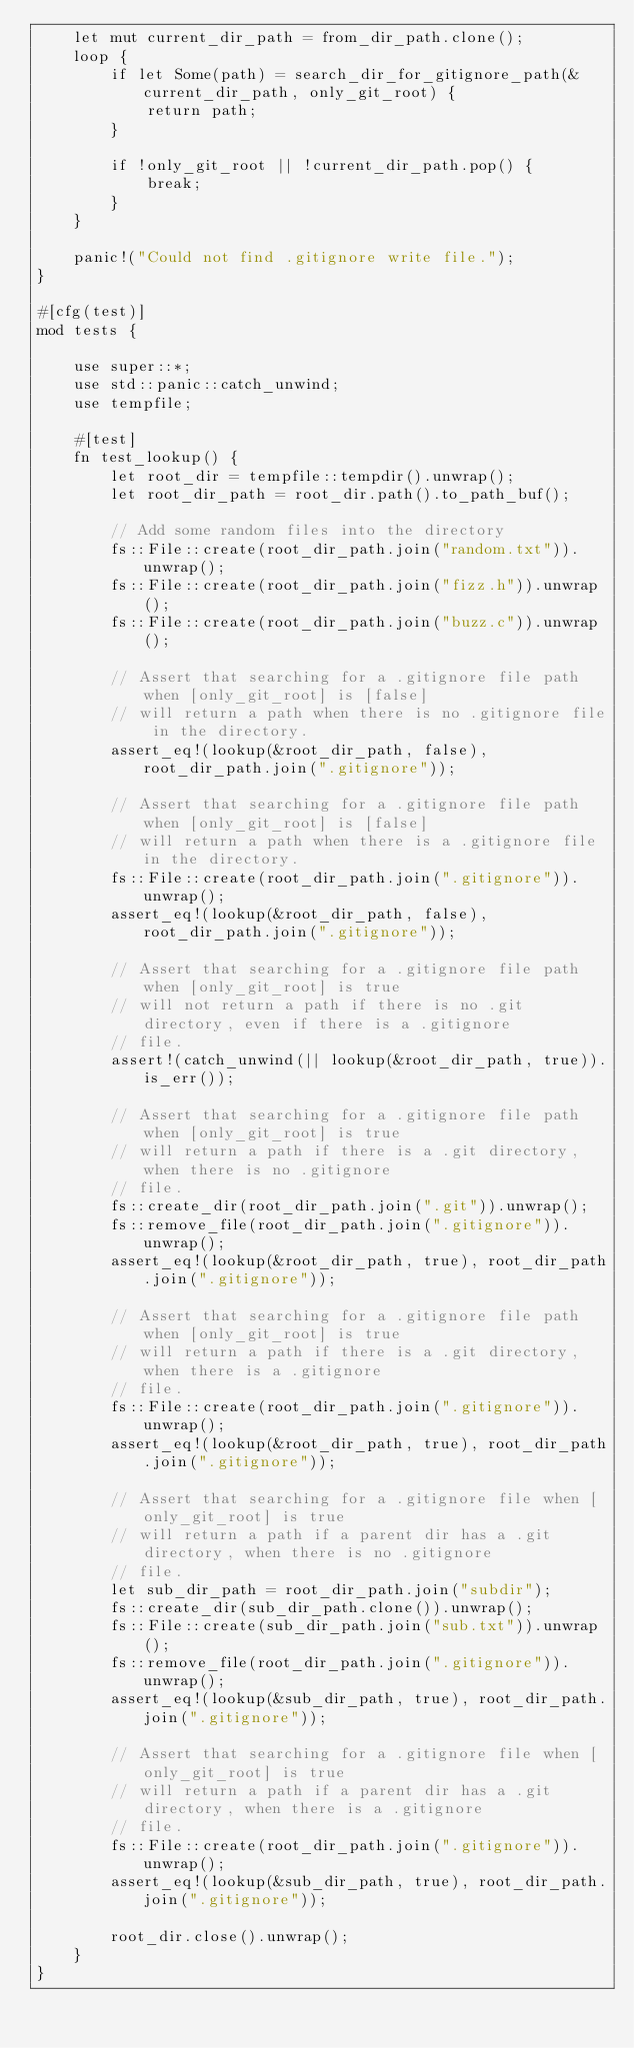<code> <loc_0><loc_0><loc_500><loc_500><_Rust_>    let mut current_dir_path = from_dir_path.clone();
    loop {
        if let Some(path) = search_dir_for_gitignore_path(&current_dir_path, only_git_root) {
            return path;
        }

        if !only_git_root || !current_dir_path.pop() {
            break;
        }
    }

    panic!("Could not find .gitignore write file.");
}

#[cfg(test)]
mod tests {

    use super::*;
    use std::panic::catch_unwind;
    use tempfile;

    #[test]
    fn test_lookup() {
        let root_dir = tempfile::tempdir().unwrap();
        let root_dir_path = root_dir.path().to_path_buf();

        // Add some random files into the directory
        fs::File::create(root_dir_path.join("random.txt")).unwrap();
        fs::File::create(root_dir_path.join("fizz.h")).unwrap();
        fs::File::create(root_dir_path.join("buzz.c")).unwrap();

        // Assert that searching for a .gitignore file path when [only_git_root] is [false]
        // will return a path when there is no .gitignore file in the directory.
        assert_eq!(lookup(&root_dir_path, false), root_dir_path.join(".gitignore"));

        // Assert that searching for a .gitignore file path when [only_git_root] is [false]
        // will return a path when there is a .gitignore file in the directory.
        fs::File::create(root_dir_path.join(".gitignore")).unwrap();
        assert_eq!(lookup(&root_dir_path, false), root_dir_path.join(".gitignore"));

        // Assert that searching for a .gitignore file path when [only_git_root] is true
        // will not return a path if there is no .git directory, even if there is a .gitignore
        // file.
        assert!(catch_unwind(|| lookup(&root_dir_path, true)).is_err());

        // Assert that searching for a .gitignore file path when [only_git_root] is true
        // will return a path if there is a .git directory, when there is no .gitignore
        // file.
        fs::create_dir(root_dir_path.join(".git")).unwrap();
        fs::remove_file(root_dir_path.join(".gitignore")).unwrap();
        assert_eq!(lookup(&root_dir_path, true), root_dir_path.join(".gitignore"));

        // Assert that searching for a .gitignore file path when [only_git_root] is true
        // will return a path if there is a .git directory, when there is a .gitignore
        // file.
        fs::File::create(root_dir_path.join(".gitignore")).unwrap();
        assert_eq!(lookup(&root_dir_path, true), root_dir_path.join(".gitignore"));

        // Assert that searching for a .gitignore file when [only_git_root] is true
        // will return a path if a parent dir has a .git directory, when there is no .gitignore
        // file.
        let sub_dir_path = root_dir_path.join("subdir");
        fs::create_dir(sub_dir_path.clone()).unwrap();
        fs::File::create(sub_dir_path.join("sub.txt")).unwrap();
        fs::remove_file(root_dir_path.join(".gitignore")).unwrap();
        assert_eq!(lookup(&sub_dir_path, true), root_dir_path.join(".gitignore"));

        // Assert that searching for a .gitignore file when [only_git_root] is true
        // will return a path if a parent dir has a .git directory, when there is a .gitignore
        // file.
        fs::File::create(root_dir_path.join(".gitignore")).unwrap();
        assert_eq!(lookup(&sub_dir_path, true), root_dir_path.join(".gitignore"));

        root_dir.close().unwrap();
    }
}

</code> 